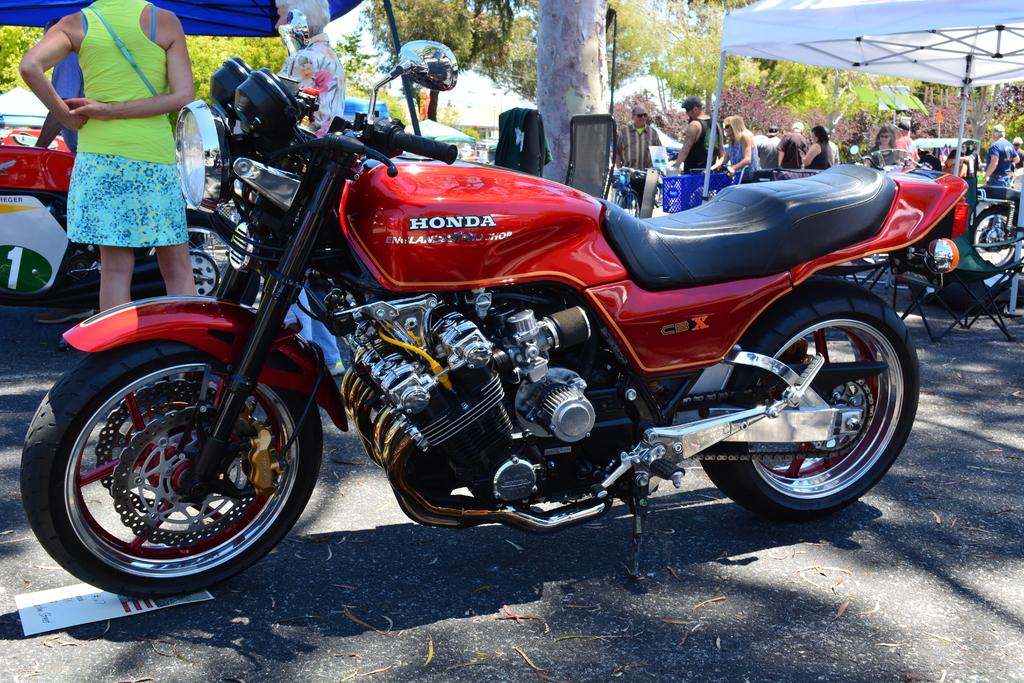What types of objects can be seen in the image? There are vehicles, tents, people, trees, and other objects in the image. Can you describe the setting of the image? The image features a camping-like setting, with tents and trees present. What is the purpose of the paper under the vehicle in the image? The purpose of the paper under the vehicle is not clear from the image. How many people are visible in the image? There are people in the image, but the exact number is not specified. What type of scent can be smelled coming from the turkey in the image? There is no turkey present in the image, so it is not possible to determine any associated scent. What type of scarecrow is standing near the tents in the image? There is no scarecrow present in the image; only tents, trees, vehicles, people, and objects are visible. 